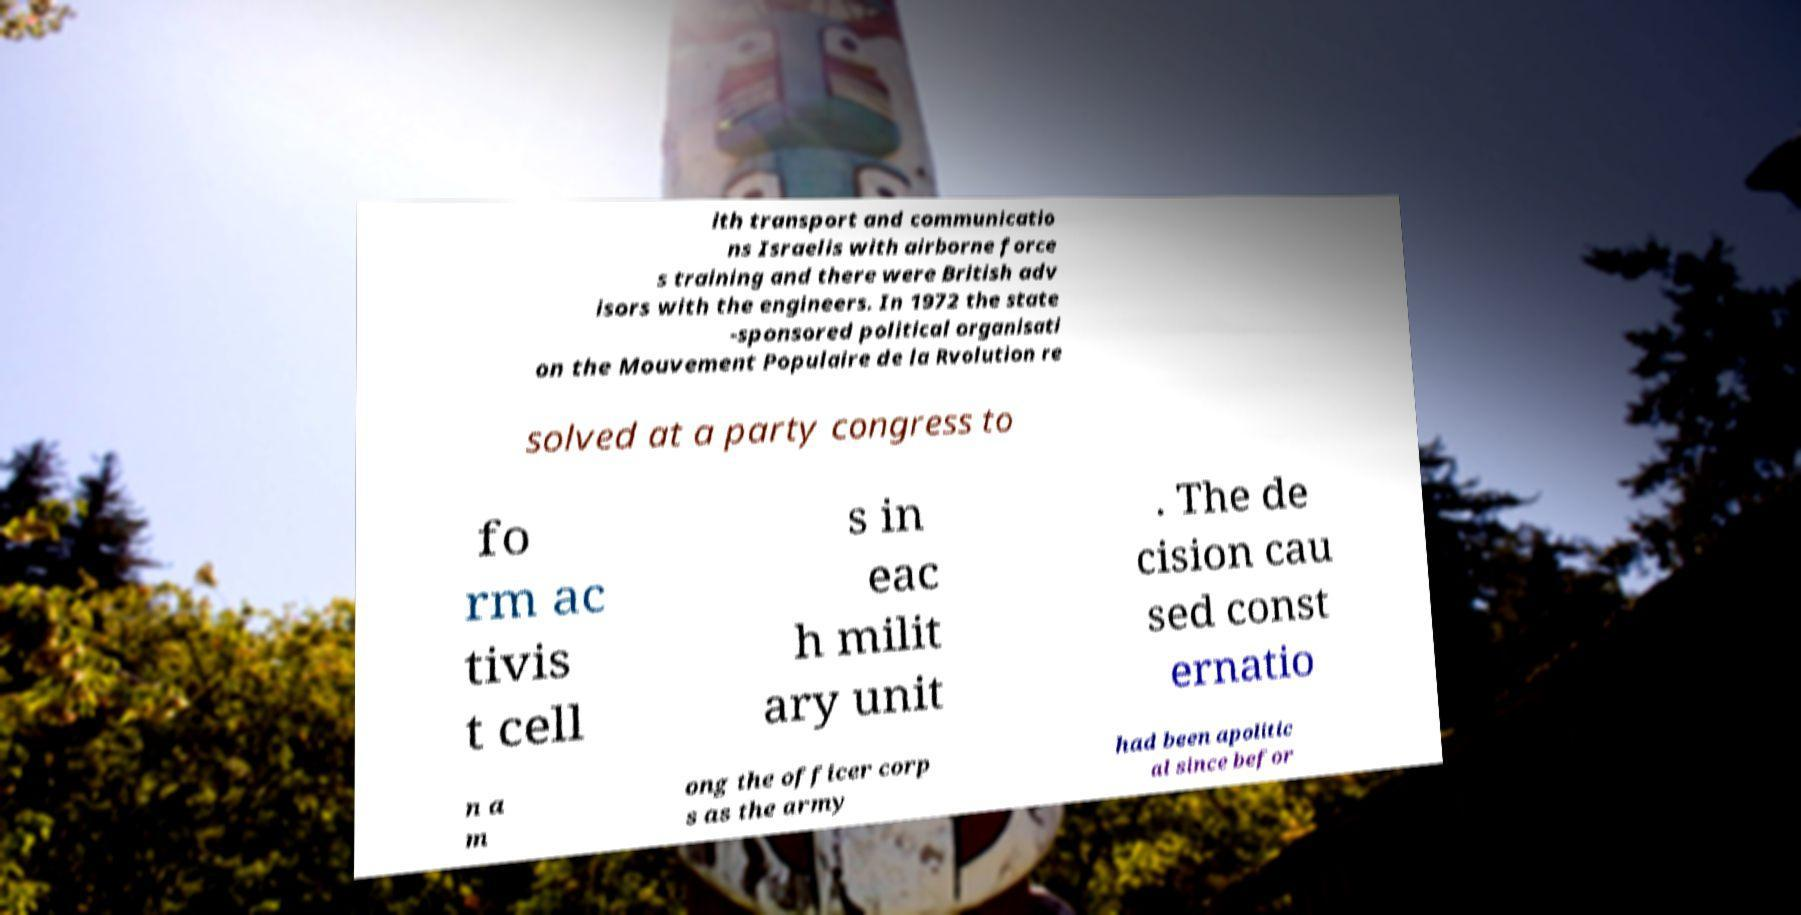There's text embedded in this image that I need extracted. Can you transcribe it verbatim? ith transport and communicatio ns Israelis with airborne force s training and there were British adv isors with the engineers. In 1972 the state -sponsored political organisati on the Mouvement Populaire de la Rvolution re solved at a party congress to fo rm ac tivis t cell s in eac h milit ary unit . The de cision cau sed const ernatio n a m ong the officer corp s as the army had been apolitic al since befor 